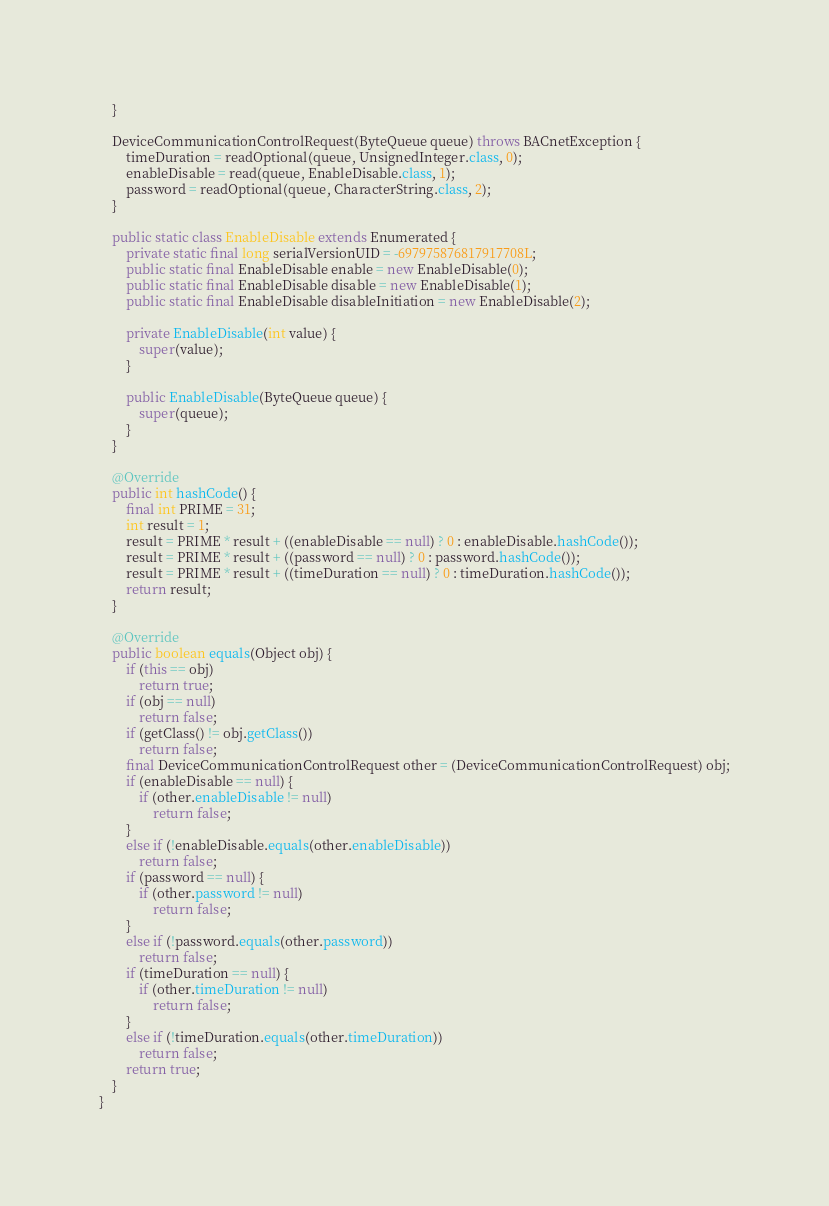Convert code to text. <code><loc_0><loc_0><loc_500><loc_500><_Java_>    }

    DeviceCommunicationControlRequest(ByteQueue queue) throws BACnetException {
        timeDuration = readOptional(queue, UnsignedInteger.class, 0);
        enableDisable = read(queue, EnableDisable.class, 1);
        password = readOptional(queue, CharacterString.class, 2);
    }

    public static class EnableDisable extends Enumerated {
        private static final long serialVersionUID = -697975876817917708L;
        public static final EnableDisable enable = new EnableDisable(0);
        public static final EnableDisable disable = new EnableDisable(1);
        public static final EnableDisable disableInitiation = new EnableDisable(2);

        private EnableDisable(int value) {
            super(value);
        }

        public EnableDisable(ByteQueue queue) {
            super(queue);
        }
    }

    @Override
    public int hashCode() {
        final int PRIME = 31;
        int result = 1;
        result = PRIME * result + ((enableDisable == null) ? 0 : enableDisable.hashCode());
        result = PRIME * result + ((password == null) ? 0 : password.hashCode());
        result = PRIME * result + ((timeDuration == null) ? 0 : timeDuration.hashCode());
        return result;
    }

    @Override
    public boolean equals(Object obj) {
        if (this == obj)
            return true;
        if (obj == null)
            return false;
        if (getClass() != obj.getClass())
            return false;
        final DeviceCommunicationControlRequest other = (DeviceCommunicationControlRequest) obj;
        if (enableDisable == null) {
            if (other.enableDisable != null)
                return false;
        }
        else if (!enableDisable.equals(other.enableDisable))
            return false;
        if (password == null) {
            if (other.password != null)
                return false;
        }
        else if (!password.equals(other.password))
            return false;
        if (timeDuration == null) {
            if (other.timeDuration != null)
                return false;
        }
        else if (!timeDuration.equals(other.timeDuration))
            return false;
        return true;
    }
}
</code> 